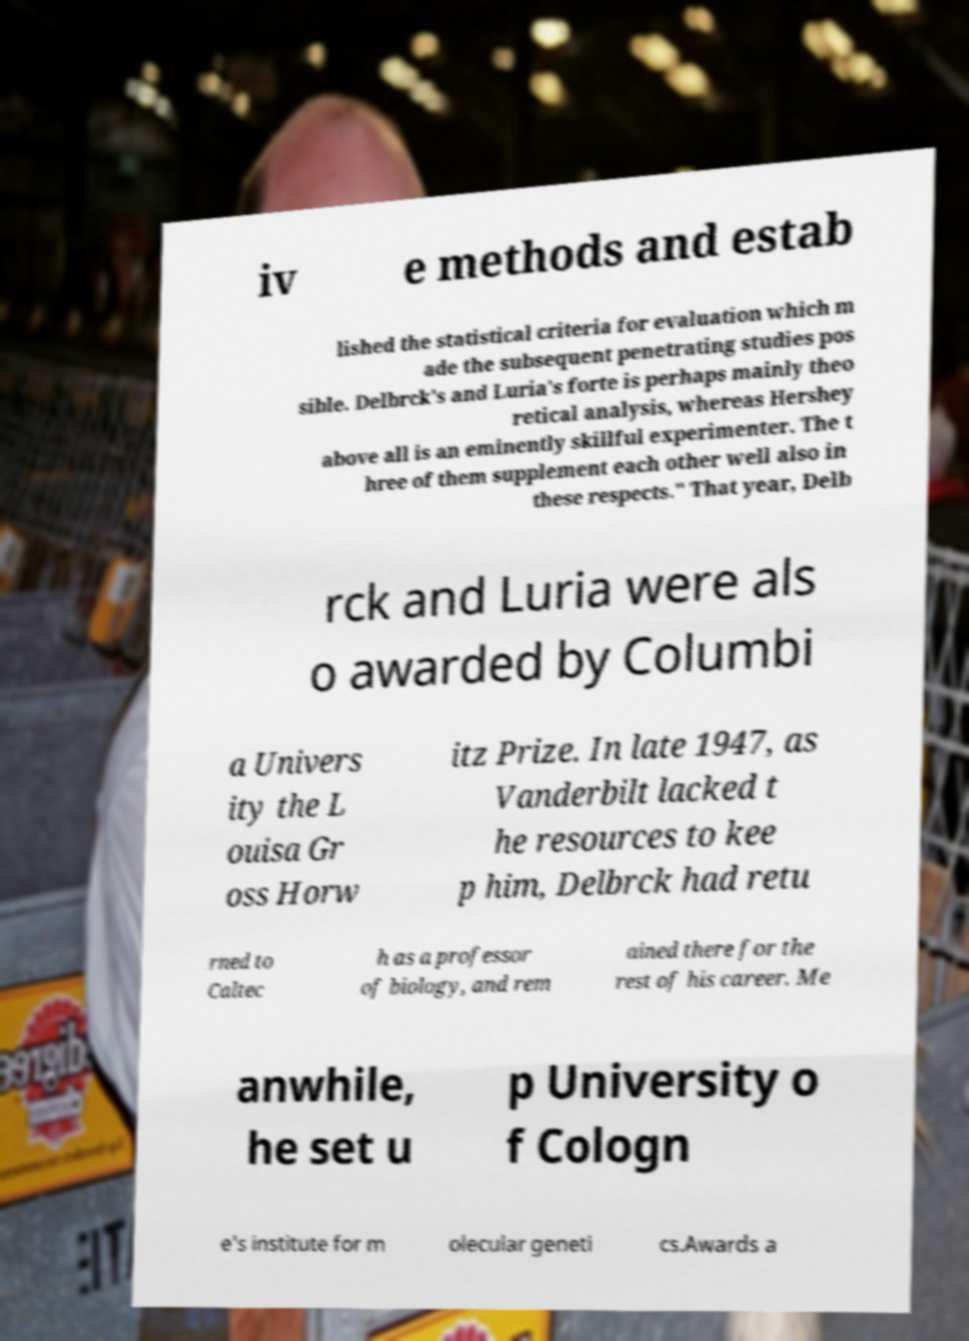For documentation purposes, I need the text within this image transcribed. Could you provide that? iv e methods and estab lished the statistical criteria for evaluation which m ade the subsequent penetrating studies pos sible. Delbrck's and Luria's forte is perhaps mainly theo retical analysis, whereas Hershey above all is an eminently skillful experimenter. The t hree of them supplement each other well also in these respects." That year, Delb rck and Luria were als o awarded by Columbi a Univers ity the L ouisa Gr oss Horw itz Prize. In late 1947, as Vanderbilt lacked t he resources to kee p him, Delbrck had retu rned to Caltec h as a professor of biology, and rem ained there for the rest of his career. Me anwhile, he set u p University o f Cologn e's institute for m olecular geneti cs.Awards a 